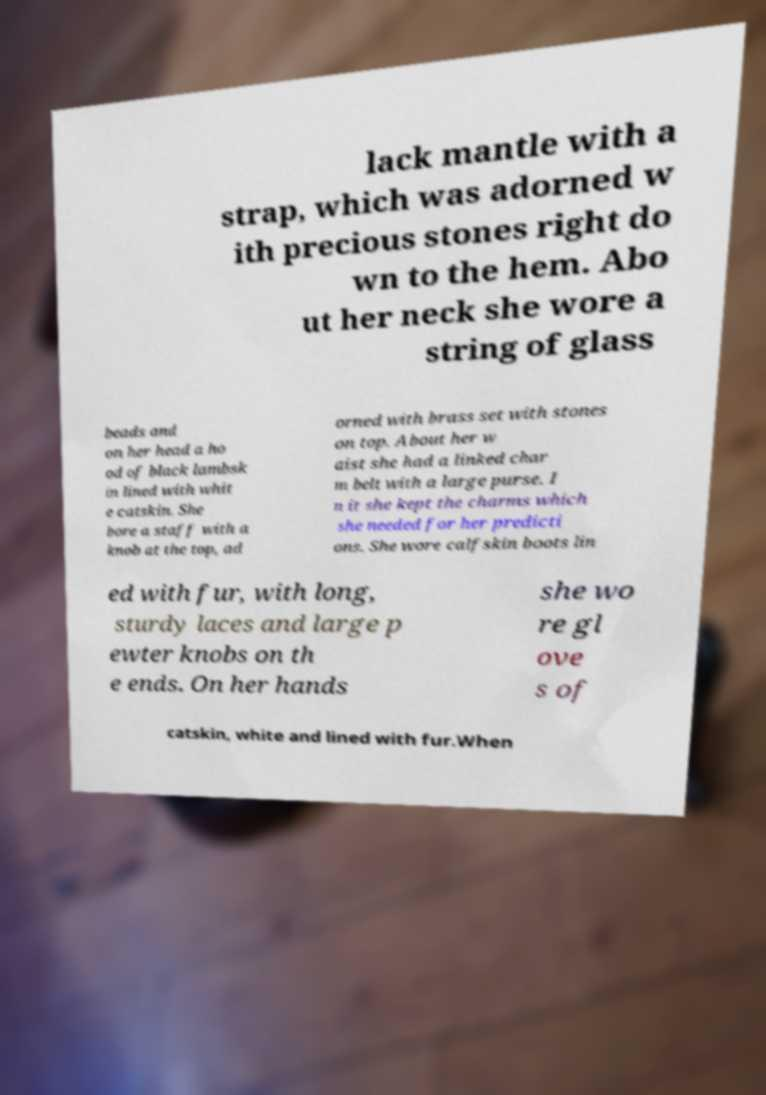Please read and relay the text visible in this image. What does it say? lack mantle with a strap, which was adorned w ith precious stones right do wn to the hem. Abo ut her neck she wore a string of glass beads and on her head a ho od of black lambsk in lined with whit e catskin. She bore a staff with a knob at the top, ad orned with brass set with stones on top. About her w aist she had a linked char m belt with a large purse. I n it she kept the charms which she needed for her predicti ons. She wore calfskin boots lin ed with fur, with long, sturdy laces and large p ewter knobs on th e ends. On her hands she wo re gl ove s of catskin, white and lined with fur.When 